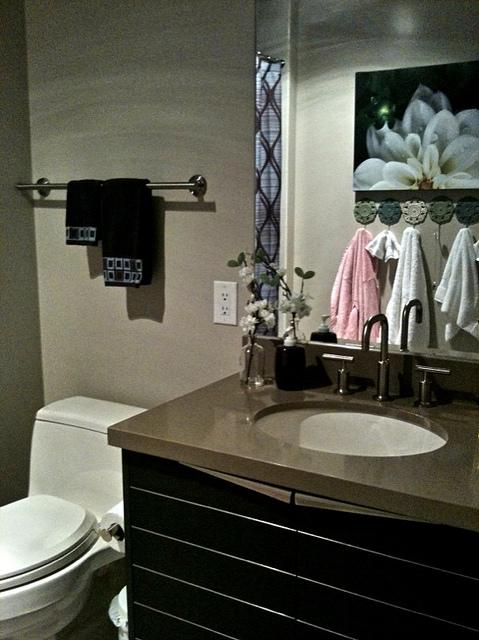What is likely opposite the toilet? shower 